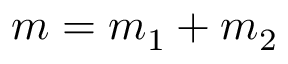Convert formula to latex. <formula><loc_0><loc_0><loc_500><loc_500>m = m _ { 1 } + m _ { 2 }</formula> 